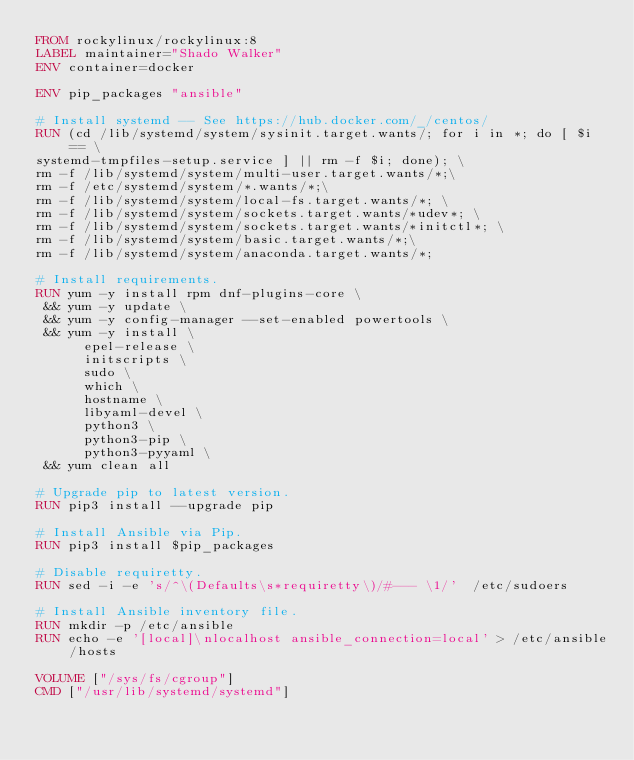<code> <loc_0><loc_0><loc_500><loc_500><_Dockerfile_>FROM rockylinux/rockylinux:8
LABEL maintainer="Shado Walker"
ENV container=docker

ENV pip_packages "ansible"

# Install systemd -- See https://hub.docker.com/_/centos/
RUN (cd /lib/systemd/system/sysinit.target.wants/; for i in *; do [ $i == \
systemd-tmpfiles-setup.service ] || rm -f $i; done); \
rm -f /lib/systemd/system/multi-user.target.wants/*;\
rm -f /etc/systemd/system/*.wants/*;\
rm -f /lib/systemd/system/local-fs.target.wants/*; \
rm -f /lib/systemd/system/sockets.target.wants/*udev*; \
rm -f /lib/systemd/system/sockets.target.wants/*initctl*; \
rm -f /lib/systemd/system/basic.target.wants/*;\
rm -f /lib/systemd/system/anaconda.target.wants/*;

# Install requirements.
RUN yum -y install rpm dnf-plugins-core \
 && yum -y update \
 && yum -y config-manager --set-enabled powertools \
 && yum -y install \
      epel-release \
      initscripts \
      sudo \
      which \
      hostname \
      libyaml-devel \
      python3 \
      python3-pip \
      python3-pyyaml \
 && yum clean all

# Upgrade pip to latest version.
RUN pip3 install --upgrade pip

# Install Ansible via Pip.
RUN pip3 install $pip_packages

# Disable requiretty.
RUN sed -i -e 's/^\(Defaults\s*requiretty\)/#--- \1/'  /etc/sudoers

# Install Ansible inventory file.
RUN mkdir -p /etc/ansible
RUN echo -e '[local]\nlocalhost ansible_connection=local' > /etc/ansible/hosts

VOLUME ["/sys/fs/cgroup"]
CMD ["/usr/lib/systemd/systemd"]
</code> 